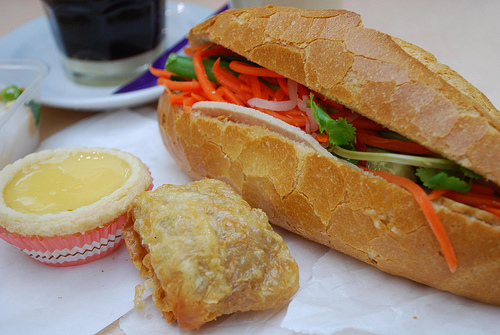<image>
Is there a carrot in the bun? No. The carrot is not contained within the bun. These objects have a different spatial relationship. Is the sandwich in front of the soda? Yes. The sandwich is positioned in front of the soda, appearing closer to the camera viewpoint. 